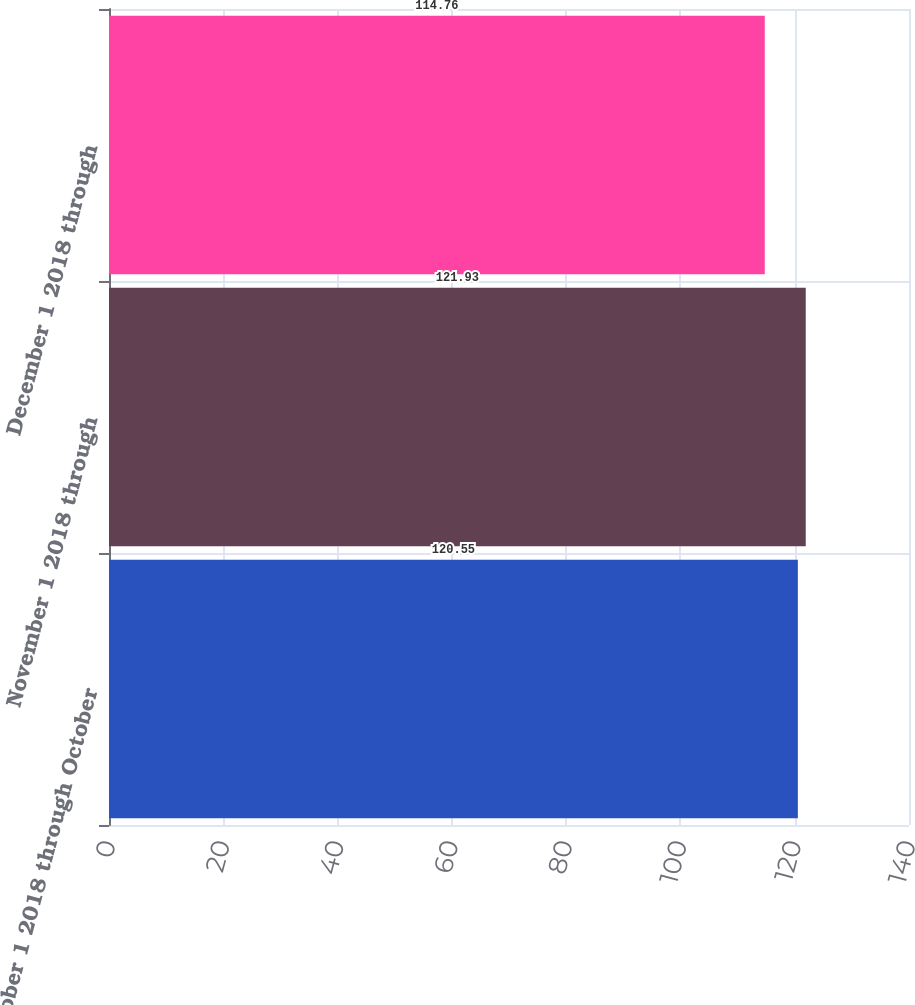Convert chart. <chart><loc_0><loc_0><loc_500><loc_500><bar_chart><fcel>October 1 2018 through October<fcel>November 1 2018 through<fcel>December 1 2018 through<nl><fcel>120.55<fcel>121.93<fcel>114.76<nl></chart> 